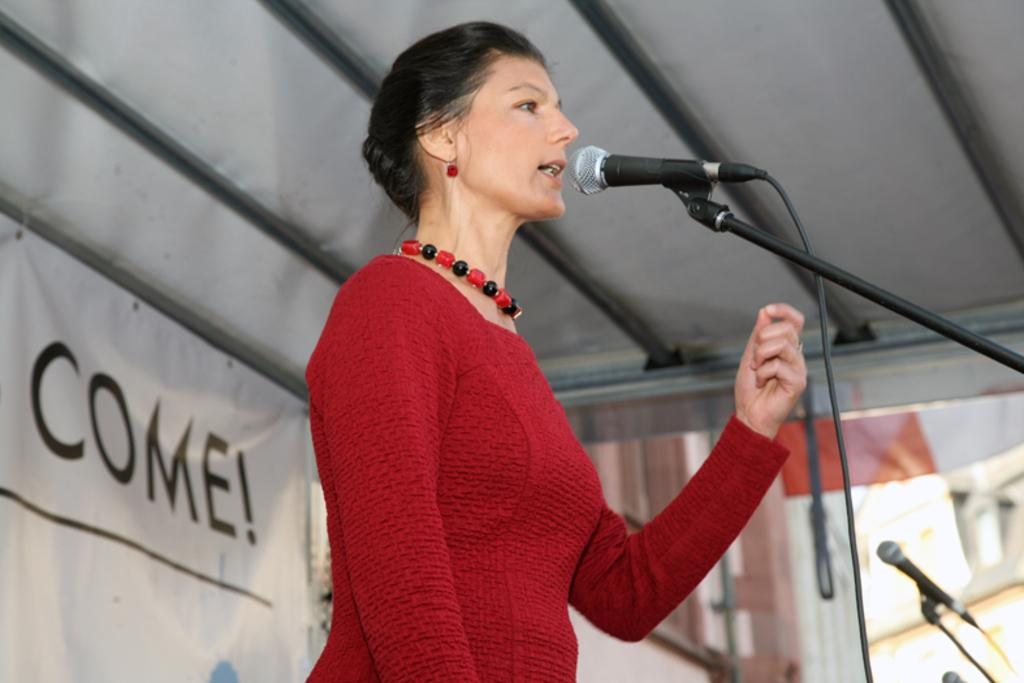Who is the main subject in the image? There is a lady in the image. What is the lady doing in the image? The lady is talking. Are there any animals present in the image? Yes, there are mice in the image. What type of structure can be seen in the image? There is a shed in the image. What else can be seen in the image besides the lady, mice, and shed? There is a banner with text in the image. How many passengers are visible in the image? There are no passengers present in the image; it only features a lady, mice, a shed, and a banner with text. What type of bird can be seen flying in the image? There are no birds present in the image; it only features a lady, mice, a shed, and a banner. 